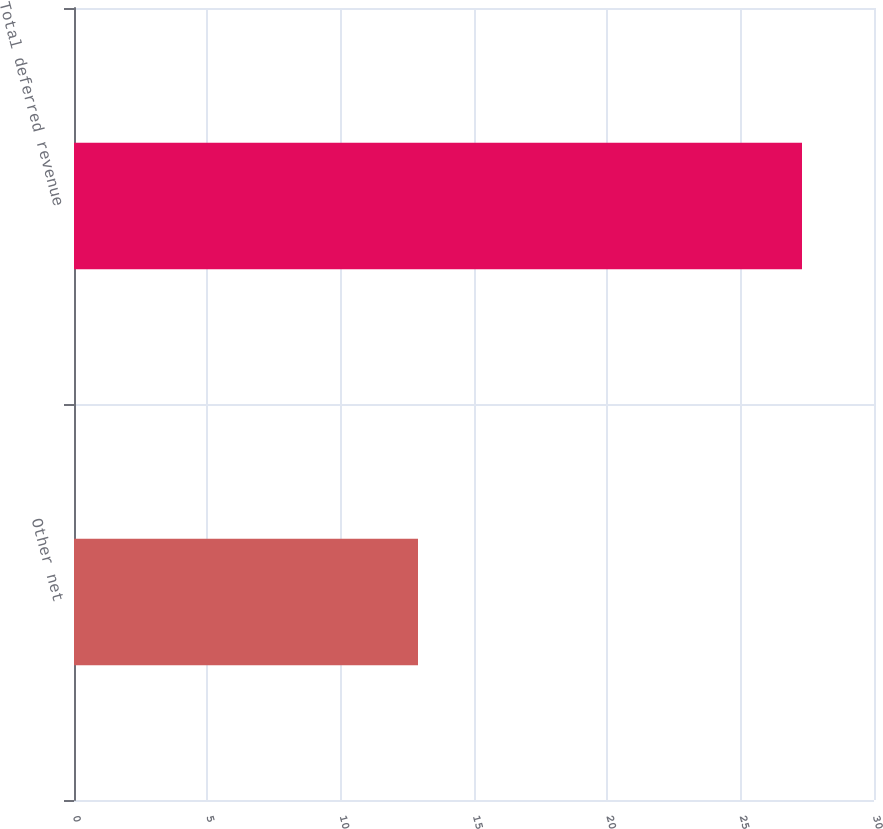<chart> <loc_0><loc_0><loc_500><loc_500><bar_chart><fcel>Other net<fcel>Total deferred revenue<nl><fcel>12.9<fcel>27.3<nl></chart> 